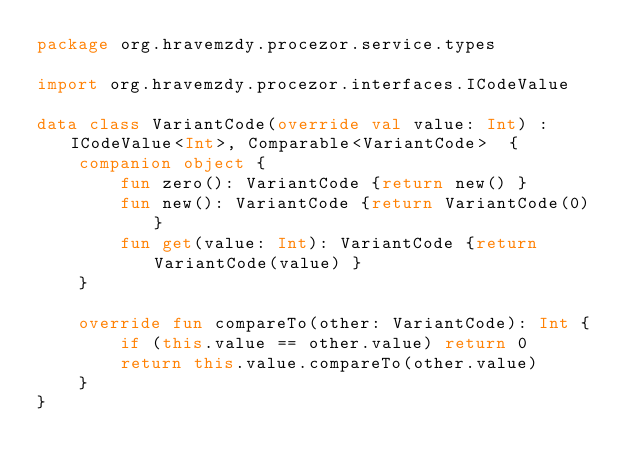Convert code to text. <code><loc_0><loc_0><loc_500><loc_500><_Kotlin_>package org.hravemzdy.procezor.service.types

import org.hravemzdy.procezor.interfaces.ICodeValue

data class VariantCode(override val value: Int) : ICodeValue<Int>, Comparable<VariantCode>  {
    companion object {
        fun zero(): VariantCode {return new() }
        fun new(): VariantCode {return VariantCode(0) }
        fun get(value: Int): VariantCode {return VariantCode(value) }
    }

    override fun compareTo(other: VariantCode): Int {
        if (this.value == other.value) return 0
        return this.value.compareTo(other.value)
    }
}
</code> 